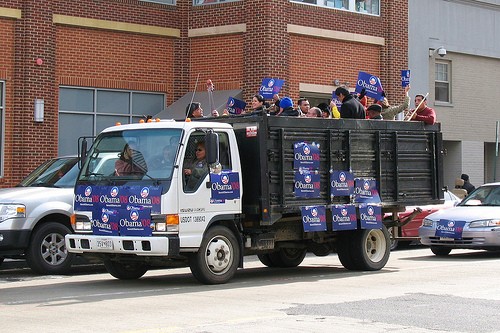Please provide a short description for this region: [0.55, 0.35, 0.59, 0.39]. A man wearing a bright blue stocking cap can be seen in the distance, but his face and body are mostly obscured. 